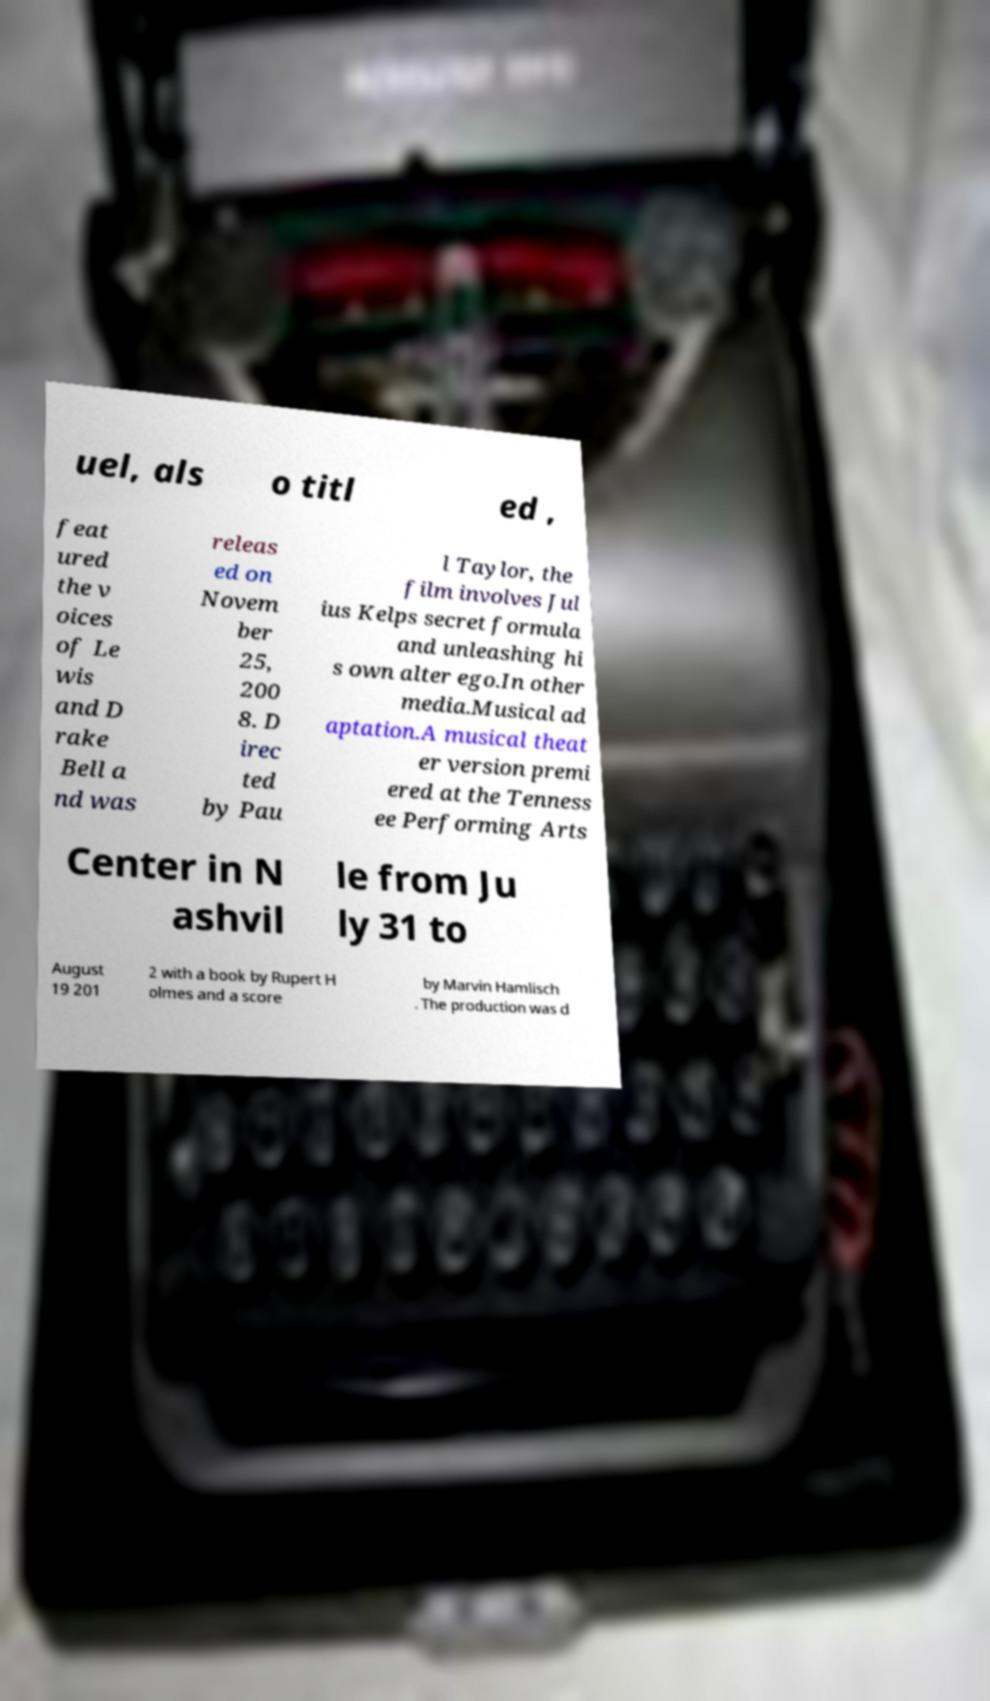For documentation purposes, I need the text within this image transcribed. Could you provide that? uel, als o titl ed , feat ured the v oices of Le wis and D rake Bell a nd was releas ed on Novem ber 25, 200 8. D irec ted by Pau l Taylor, the film involves Jul ius Kelps secret formula and unleashing hi s own alter ego.In other media.Musical ad aptation.A musical theat er version premi ered at the Tenness ee Performing Arts Center in N ashvil le from Ju ly 31 to August 19 201 2 with a book by Rupert H olmes and a score by Marvin Hamlisch . The production was d 